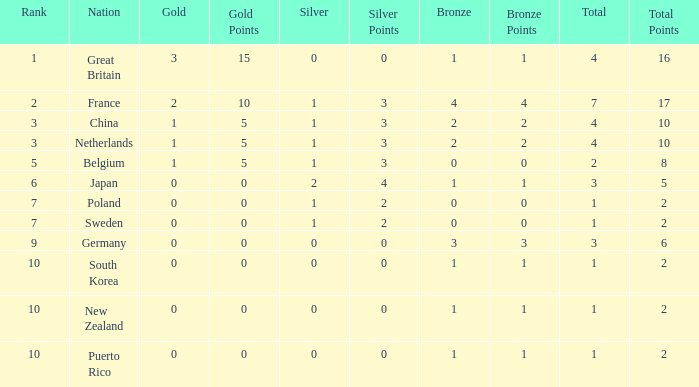What is the total where the gold is larger than 2? 1.0. 